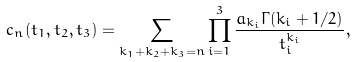Convert formula to latex. <formula><loc_0><loc_0><loc_500><loc_500>c _ { n } ( t _ { 1 } , t _ { 2 } , t _ { 3 } ) = \sum _ { k _ { 1 } + k _ { 2 } + k _ { 3 } = n } \prod _ { i = 1 } ^ { 3 } \frac { a _ { k _ { i } } \Gamma ( k _ { i } + 1 / 2 ) } { t _ { i } ^ { k _ { i } } } ,</formula> 